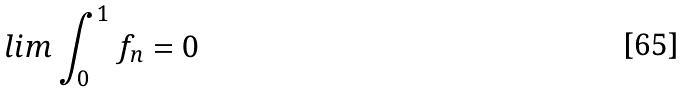Convert formula to latex. <formula><loc_0><loc_0><loc_500><loc_500>l i m \int _ { 0 } ^ { 1 } f _ { n } = 0</formula> 